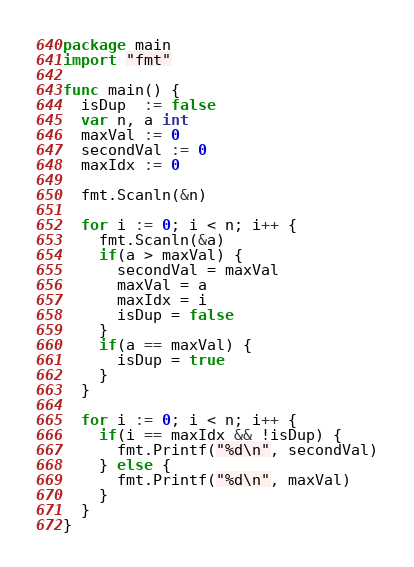Convert code to text. <code><loc_0><loc_0><loc_500><loc_500><_Go_>package main
import "fmt"
 
func main() {
  isDup  := false
  var n, a int
  maxVal := 0
  secondVal := 0
  maxIdx := 0
  
  fmt.Scanln(&n)
  
  for i := 0; i < n; i++ {
    fmt.Scanln(&a)
    if(a > maxVal) {
      secondVal = maxVal
      maxVal = a
      maxIdx = i
      isDup = false
    }
    if(a == maxVal) {
      isDup = true
    }
  }
  
  for i := 0; i < n; i++ {
    if(i == maxIdx && !isDup) {
      fmt.Printf("%d\n", secondVal)
    } else {
      fmt.Printf("%d\n", maxVal)
    }
  }
}</code> 